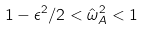<formula> <loc_0><loc_0><loc_500><loc_500>1 - \epsilon ^ { 2 } / 2 < \hat { \omega } _ { A } ^ { 2 } < 1</formula> 